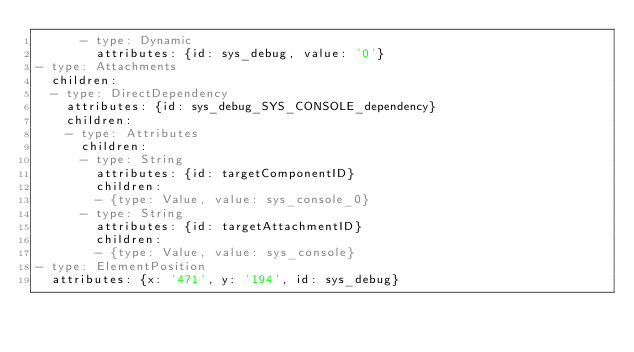Convert code to text. <code><loc_0><loc_0><loc_500><loc_500><_YAML_>      - type: Dynamic
        attributes: {id: sys_debug, value: '0'}
- type: Attachments
  children:
  - type: DirectDependency
    attributes: {id: sys_debug_SYS_CONSOLE_dependency}
    children:
    - type: Attributes
      children:
      - type: String
        attributes: {id: targetComponentID}
        children:
        - {type: Value, value: sys_console_0}
      - type: String
        attributes: {id: targetAttachmentID}
        children:
        - {type: Value, value: sys_console}
- type: ElementPosition
  attributes: {x: '471', y: '194', id: sys_debug}
</code> 